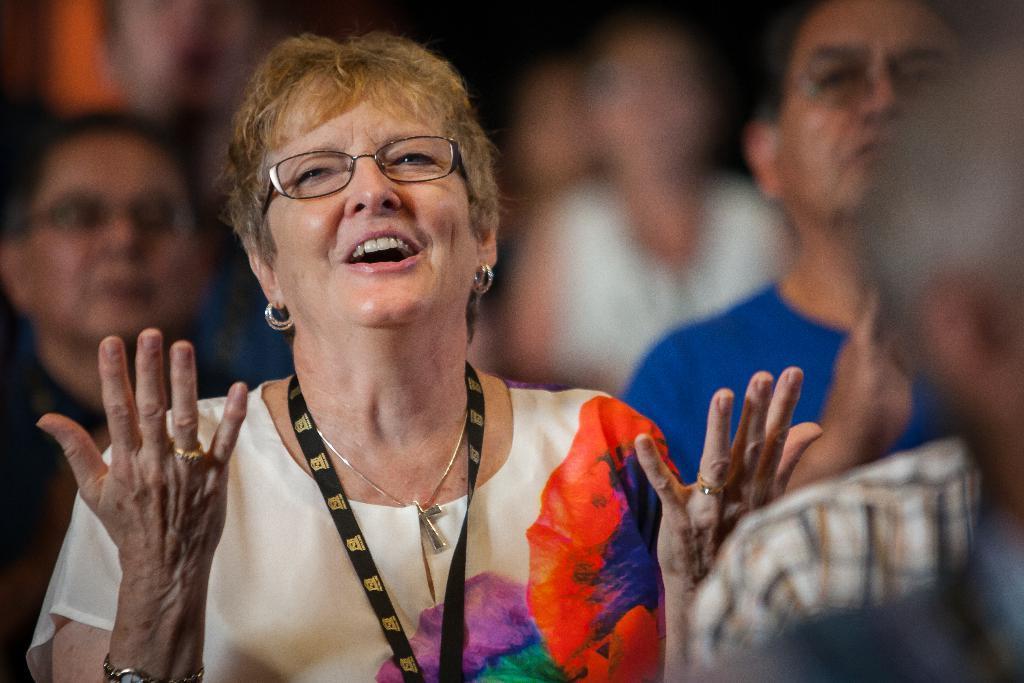In one or two sentences, can you explain what this image depicts? In this picture we can see some people here, a woman in the front wore spectacles and a tag, we can see Christianity symbol here. 